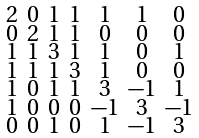<formula> <loc_0><loc_0><loc_500><loc_500>\begin{smallmatrix} 2 & 0 & 1 & 1 & 1 & 1 & 0 \\ 0 & 2 & 1 & 1 & 0 & 0 & 0 \\ 1 & 1 & 3 & 1 & 1 & 0 & 1 \\ 1 & 1 & 1 & 3 & 1 & 0 & 0 \\ 1 & 0 & 1 & 1 & 3 & - 1 & 1 \\ 1 & 0 & 0 & 0 & - 1 & 3 & - 1 \\ 0 & 0 & 1 & 0 & 1 & - 1 & 3 \end{smallmatrix}</formula> 